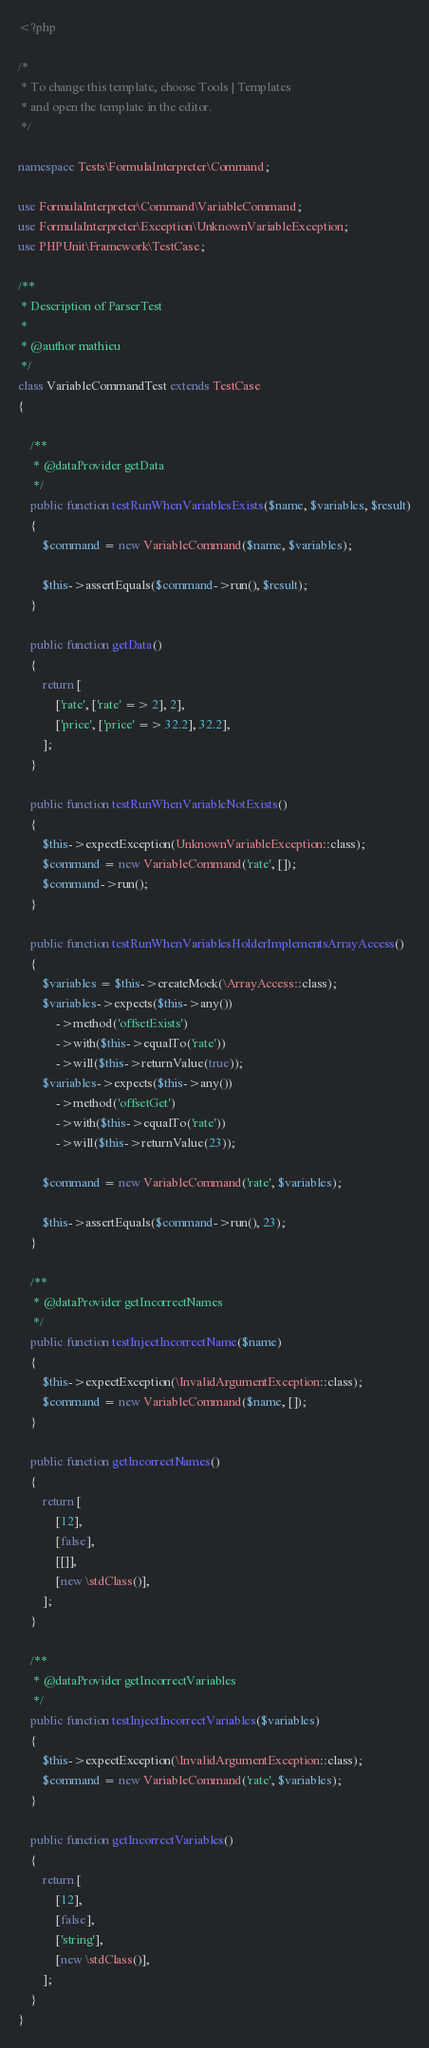<code> <loc_0><loc_0><loc_500><loc_500><_PHP_><?php

/*
 * To change this template, choose Tools | Templates
 * and open the template in the editor.
 */

namespace Tests\FormulaInterpreter\Command;

use FormulaInterpreter\Command\VariableCommand;
use FormulaInterpreter\Exception\UnknownVariableException;
use PHPUnit\Framework\TestCase;

/**
 * Description of ParserTest
 *
 * @author mathieu
 */
class VariableCommandTest extends TestCase
{

    /**
     * @dataProvider getData
     */
    public function testRunWhenVariablesExists($name, $variables, $result)
    {
        $command = new VariableCommand($name, $variables);

        $this->assertEquals($command->run(), $result);
    }

    public function getData()
    {
        return [
            ['rate', ['rate' => 2], 2],
            ['price', ['price' => 32.2], 32.2],
        ];
    }

    public function testRunWhenVariableNotExists()
    {
        $this->expectException(UnknownVariableException::class);
        $command = new VariableCommand('rate', []);
        $command->run();
    }

    public function testRunWhenVariablesHolderImplementsArrayAccess()
    {
        $variables = $this->createMock(\ArrayAccess::class);
        $variables->expects($this->any())
            ->method('offsetExists')
            ->with($this->equalTo('rate'))
            ->will($this->returnValue(true));
        $variables->expects($this->any())
            ->method('offsetGet')
            ->with($this->equalTo('rate'))
            ->will($this->returnValue(23));

        $command = new VariableCommand('rate', $variables);

        $this->assertEquals($command->run(), 23);
    }

    /**
     * @dataProvider getIncorrectNames
     */
    public function testInjectIncorrectName($name)
    {
        $this->expectException(\InvalidArgumentException::class);
        $command = new VariableCommand($name, []);
    }

    public function getIncorrectNames()
    {
        return [
            [12],
            [false],
            [[]],
            [new \stdClass()],
        ];
    }

    /**
     * @dataProvider getIncorrectVariables
     */
    public function testInjectIncorrectVariables($variables)
    {
        $this->expectException(\InvalidArgumentException::class);
        $command = new VariableCommand('rate', $variables);
    }

    public function getIncorrectVariables()
    {
        return [
            [12],
            [false],
            ['string'],
            [new \stdClass()],
        ];
    }
}
</code> 